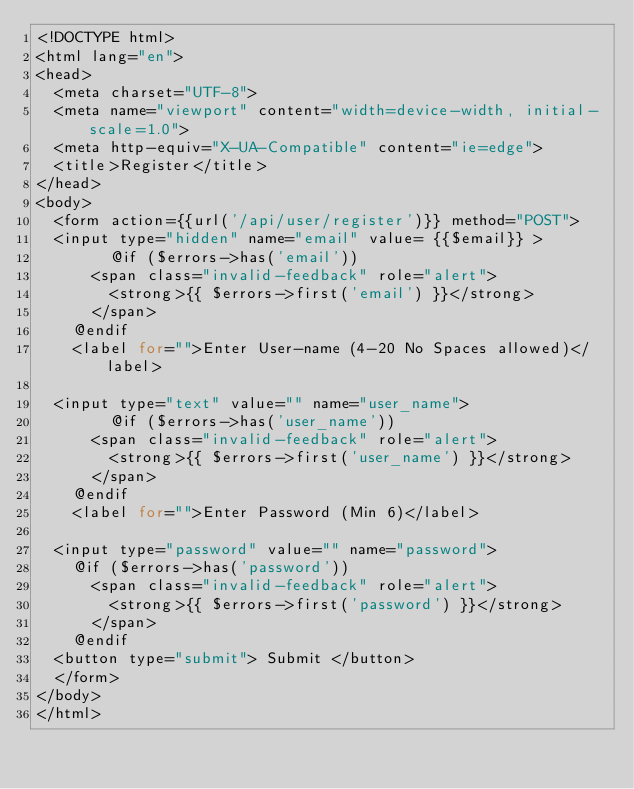Convert code to text. <code><loc_0><loc_0><loc_500><loc_500><_PHP_><!DOCTYPE html>
<html lang="en">
<head>
  <meta charset="UTF-8">
  <meta name="viewport" content="width=device-width, initial-scale=1.0">
  <meta http-equiv="X-UA-Compatible" content="ie=edge">
  <title>Register</title>
</head>
<body>
  <form action={{url('/api/user/register')}} method="POST">
  <input type="hidden" name="email" value= {{$email}} >
    	@if ($errors->has('email'))
      <span class="invalid-feedback" role="alert">
        <strong>{{ $errors->first('email') }}</strong>
      </span>
    @endif
    <label for="">Enter User-name (4-20 No Spaces allowed)</label>

  <input type="text" value="" name="user_name">
    	@if ($errors->has('user_name'))
      <span class="invalid-feedback" role="alert">
        <strong>{{ $errors->first('user_name') }}</strong>
      </span>
    @endif
    <label for="">Enter Password (Min 6)</label>

  <input type="password" value="" name="password">
  	@if ($errors->has('password'))
      <span class="invalid-feedback" role="alert">
        <strong>{{ $errors->first('password') }}</strong>
      </span>
    @endif
  <button type="submit"> Submit </button>
  </form>
</body>
</html></code> 